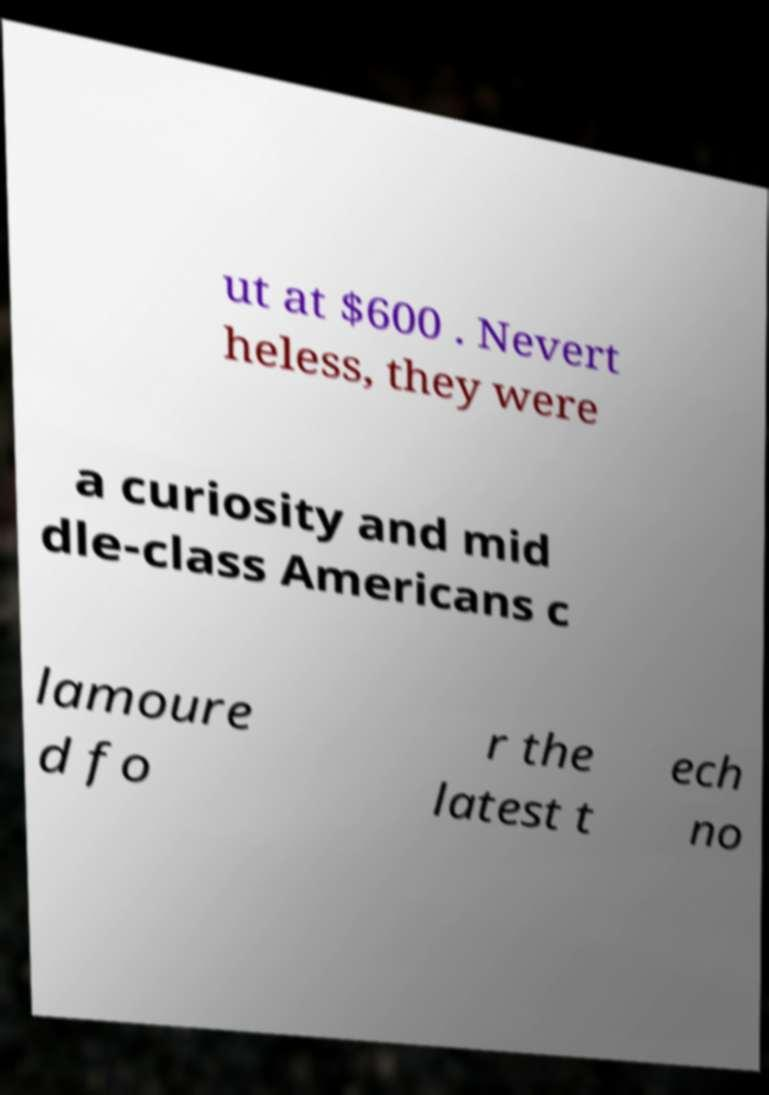For documentation purposes, I need the text within this image transcribed. Could you provide that? ut at $600 . Nevert heless, they were a curiosity and mid dle-class Americans c lamoure d fo r the latest t ech no 